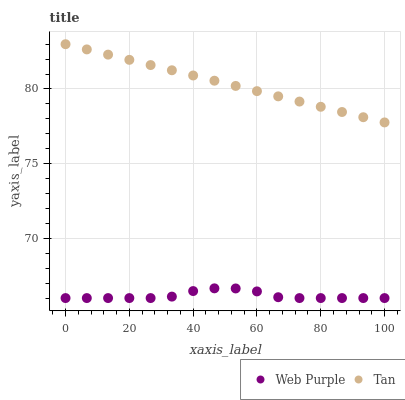Does Web Purple have the minimum area under the curve?
Answer yes or no. Yes. Does Tan have the maximum area under the curve?
Answer yes or no. Yes. Does Tan have the minimum area under the curve?
Answer yes or no. No. Is Tan the smoothest?
Answer yes or no. Yes. Is Web Purple the roughest?
Answer yes or no. Yes. Is Tan the roughest?
Answer yes or no. No. Does Web Purple have the lowest value?
Answer yes or no. Yes. Does Tan have the lowest value?
Answer yes or no. No. Does Tan have the highest value?
Answer yes or no. Yes. Is Web Purple less than Tan?
Answer yes or no. Yes. Is Tan greater than Web Purple?
Answer yes or no. Yes. Does Web Purple intersect Tan?
Answer yes or no. No. 